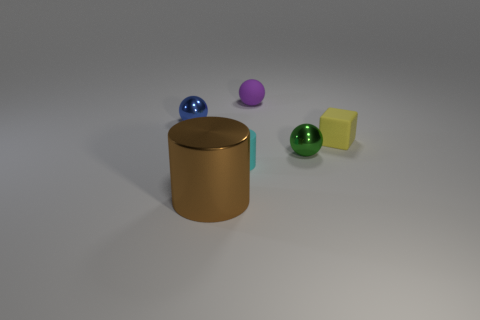What is the size of the sphere that is both right of the large brown thing and behind the small cube?
Give a very brief answer. Small. What is the size of the metal thing that is in front of the tiny metal thing in front of the rubber thing on the right side of the green object?
Keep it short and to the point. Large. The brown thing is what size?
Give a very brief answer. Large. There is a purple thing that is behind the matte thing in front of the yellow rubber object; is there a tiny ball that is to the right of it?
Offer a very short reply. Yes. How many small things are either yellow rubber objects or purple matte cylinders?
Keep it short and to the point. 1. Is there any other thing that has the same color as the small rubber cube?
Give a very brief answer. No. There is a matte object in front of the cube; does it have the same size as the small purple rubber object?
Your answer should be very brief. Yes. There is a cylinder in front of the cylinder right of the cylinder on the left side of the cyan thing; what color is it?
Keep it short and to the point. Brown. What is the color of the rubber cube?
Offer a very short reply. Yellow. Are the thing that is in front of the cyan rubber thing and the ball right of the rubber ball made of the same material?
Make the answer very short. Yes. 